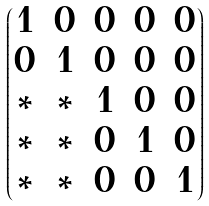<formula> <loc_0><loc_0><loc_500><loc_500>\begin{pmatrix} 1 & 0 & 0 & 0 & 0 \\ 0 & 1 & 0 & 0 & 0 \\ \ast & \ast & 1 & 0 & 0 \\ \ast & \ast & 0 & 1 & 0 \\ \ast & \ast & 0 & 0 & 1 \end{pmatrix}</formula> 